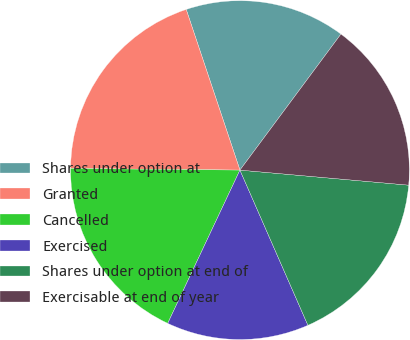<chart> <loc_0><loc_0><loc_500><loc_500><pie_chart><fcel>Shares under option at<fcel>Granted<fcel>Cancelled<fcel>Exercised<fcel>Shares under option at end of<fcel>Exercisable at end of year<nl><fcel>15.3%<fcel>19.71%<fcel>18.14%<fcel>13.58%<fcel>17.01%<fcel>16.25%<nl></chart> 